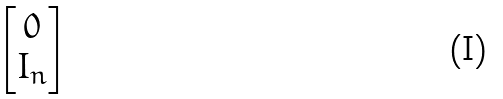Convert formula to latex. <formula><loc_0><loc_0><loc_500><loc_500>\begin{bmatrix} 0 \\ I _ { n } \end{bmatrix}</formula> 